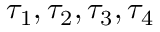Convert formula to latex. <formula><loc_0><loc_0><loc_500><loc_500>\tau _ { 1 } , \tau _ { 2 } , \tau _ { 3 } , \tau _ { 4 }</formula> 